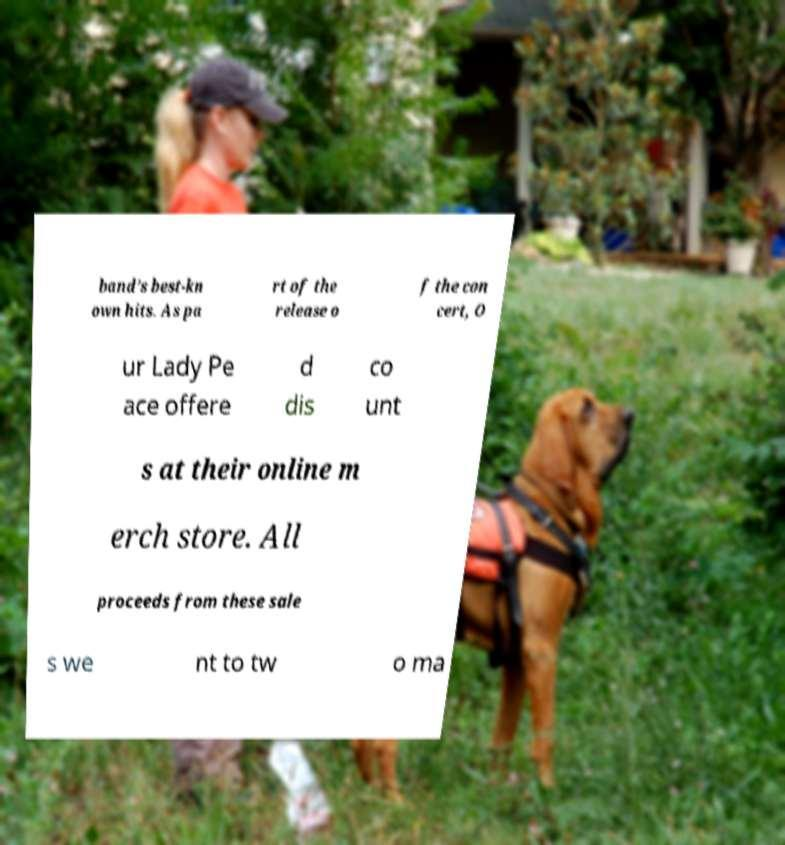There's text embedded in this image that I need extracted. Can you transcribe it verbatim? band’s best-kn own hits. As pa rt of the release o f the con cert, O ur Lady Pe ace offere d dis co unt s at their online m erch store. All proceeds from these sale s we nt to tw o ma 